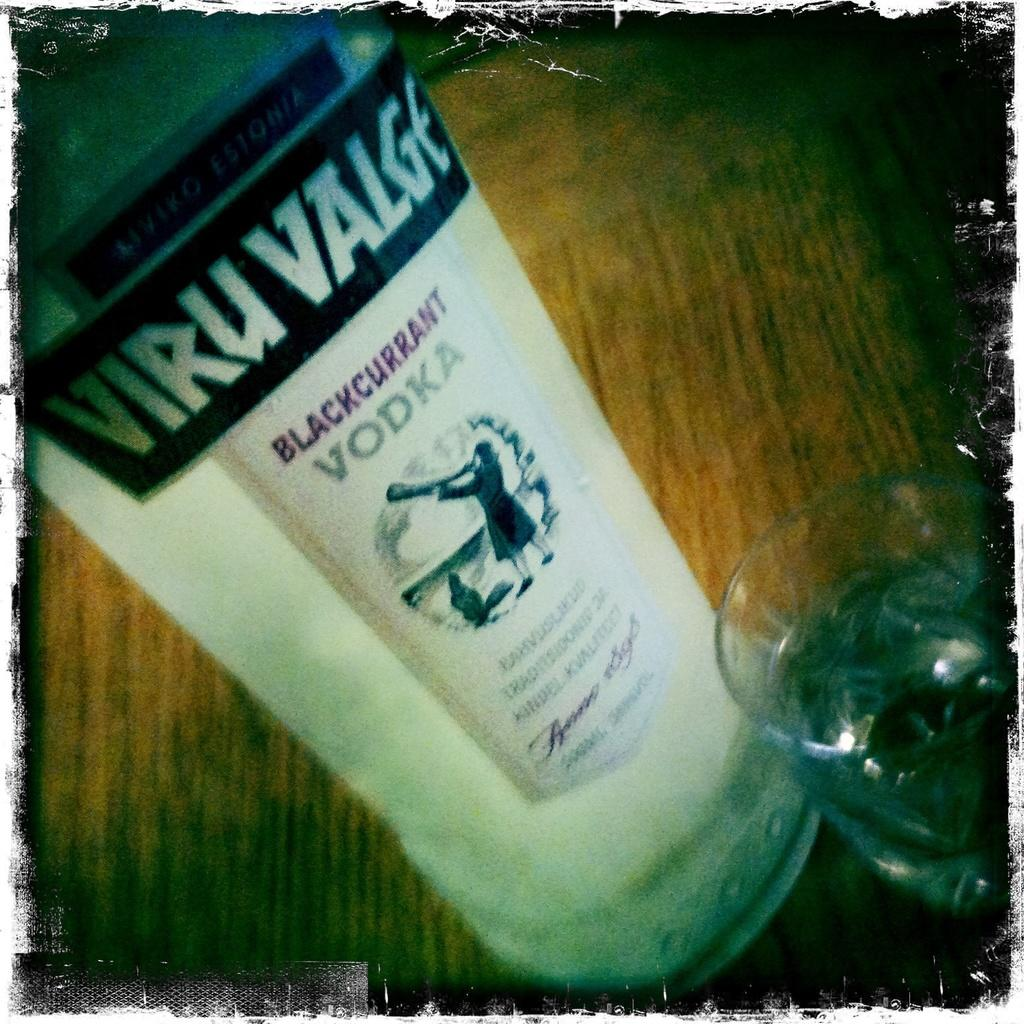Provide a one-sentence caption for the provided image. A bottle of Viru Valge vodka sitting on a table. 